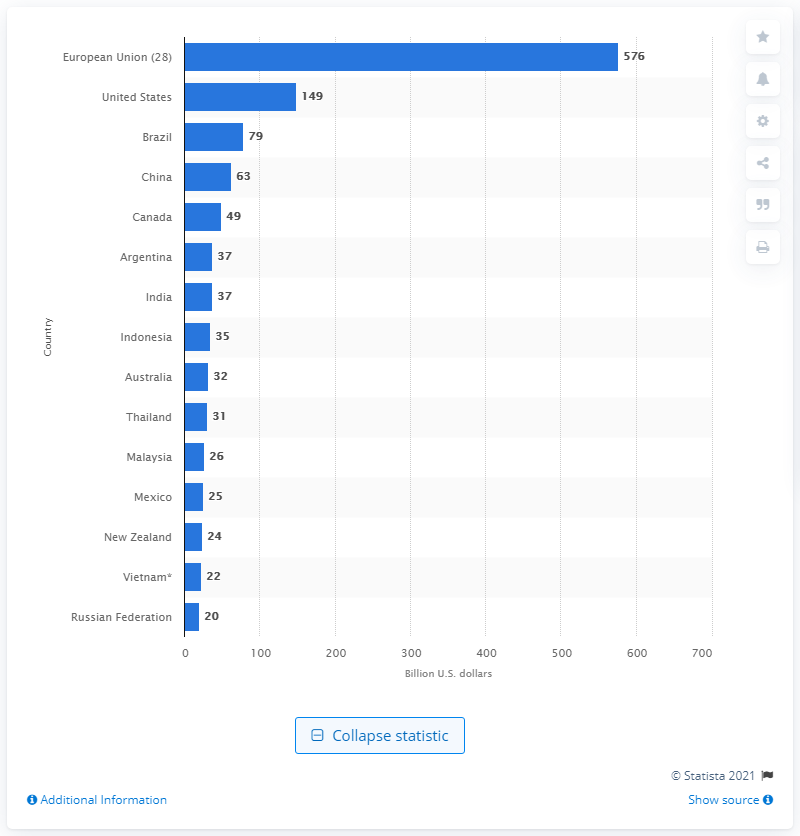List a handful of essential elements in this visual. In 2014, the value of the United States as a global food exporter was approximately $149 billion. 